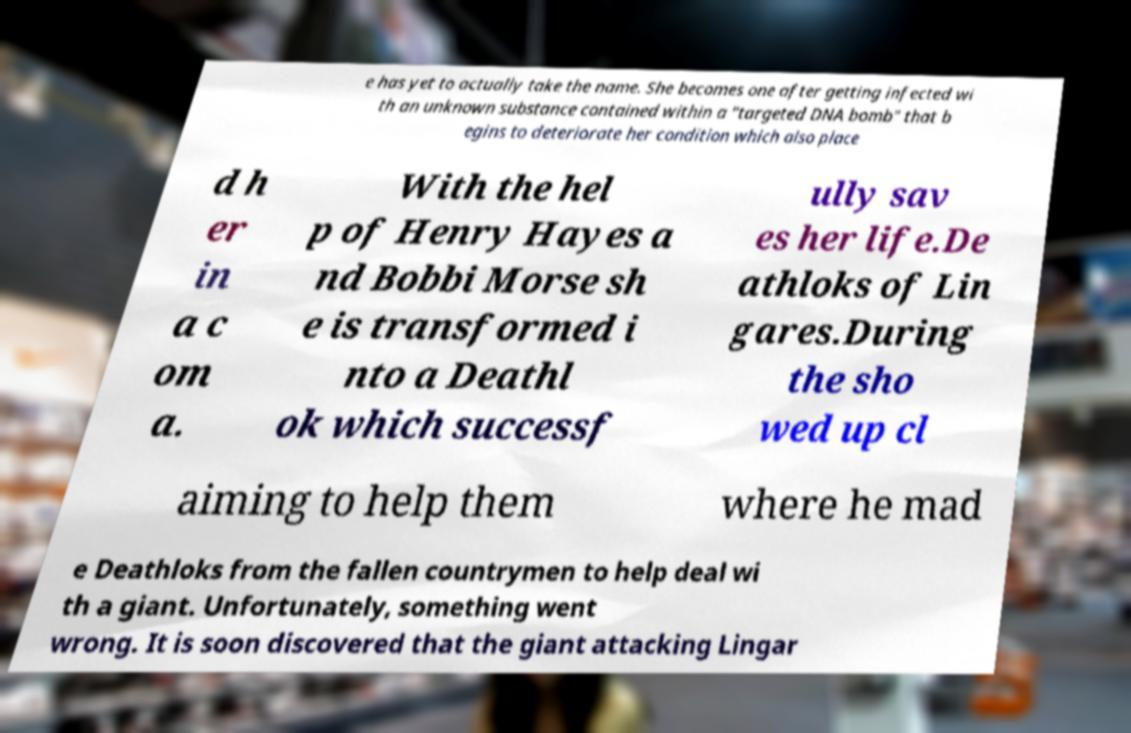Could you assist in decoding the text presented in this image and type it out clearly? e has yet to actually take the name. She becomes one after getting infected wi th an unknown substance contained within a "targeted DNA bomb" that b egins to deteriorate her condition which also place d h er in a c om a. With the hel p of Henry Hayes a nd Bobbi Morse sh e is transformed i nto a Deathl ok which successf ully sav es her life.De athloks of Lin gares.During the sho wed up cl aiming to help them where he mad e Deathloks from the fallen countrymen to help deal wi th a giant. Unfortunately, something went wrong. It is soon discovered that the giant attacking Lingar 